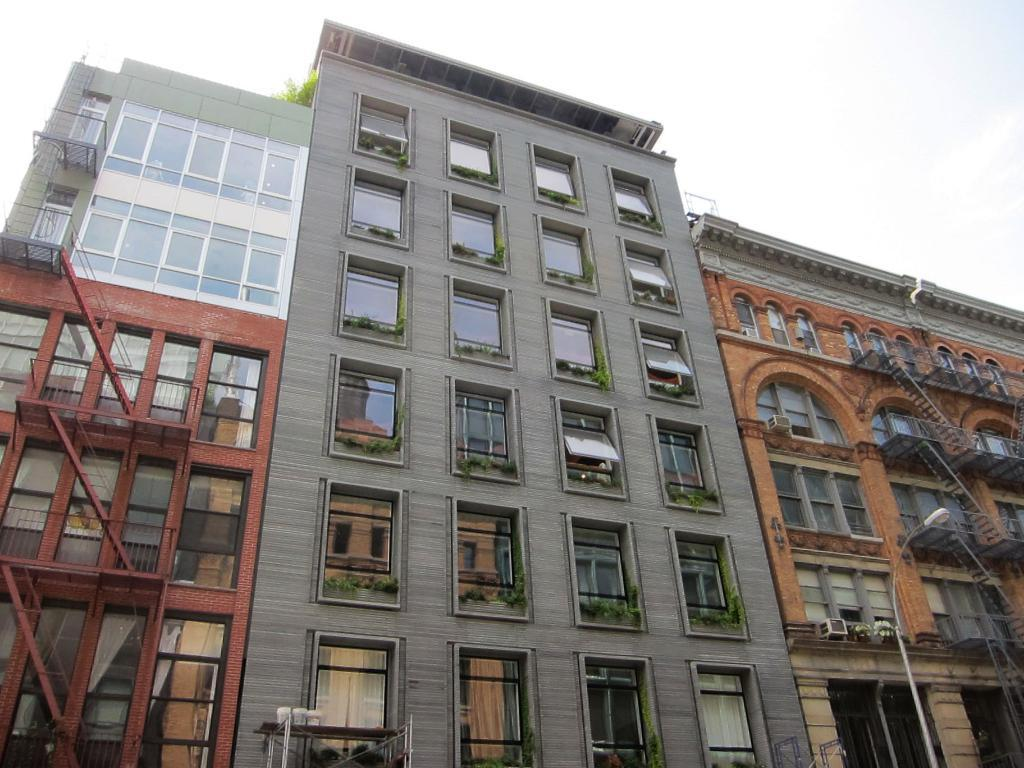What type of structures can be seen in the image? There are buildings in the image. What architectural features are present in the image? There are walls, glass windows, stairs, and railings in the image. What type of vegetation is visible in the image? There are plants in the image. What type of window treatment is present in the image? There are curtains in the image. What type of support structure is present in the image? There are rods in the image. What type of lighting fixture is visible in the image? There is a street light with a pole in the image. What can be seen in the background of the image? The sky is visible in the background of the image. What type of juice is being served in the image? There is no juice present in the image. What type of trail can be seen in the image? There is no trail present in the image. 